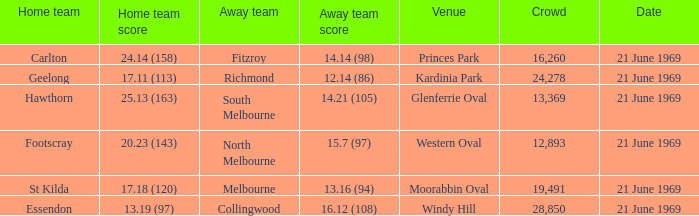What is Essendon's home team that has an away crowd size larger than 19,491? Collingwood. 